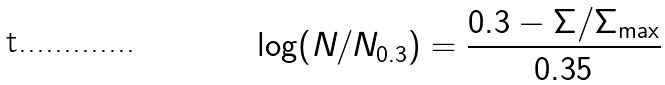Convert formula to latex. <formula><loc_0><loc_0><loc_500><loc_500>\log ( N / N _ { 0 . 3 } ) = \frac { 0 . 3 - \Sigma / \Sigma _ { \max } } { 0 . 3 5 }</formula> 